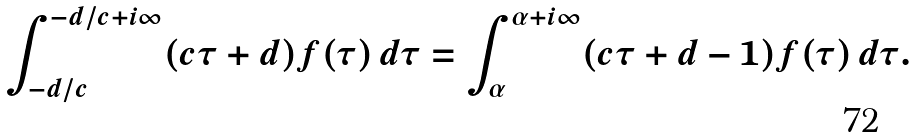<formula> <loc_0><loc_0><loc_500><loc_500>\int _ { - d / c } ^ { - d / c + i \infty } ( c \tau + d ) f ( \tau ) \, d \tau = \int _ { \alpha } ^ { \alpha + i \infty } ( c \tau + d - 1 ) f ( \tau ) \, d \tau .</formula> 